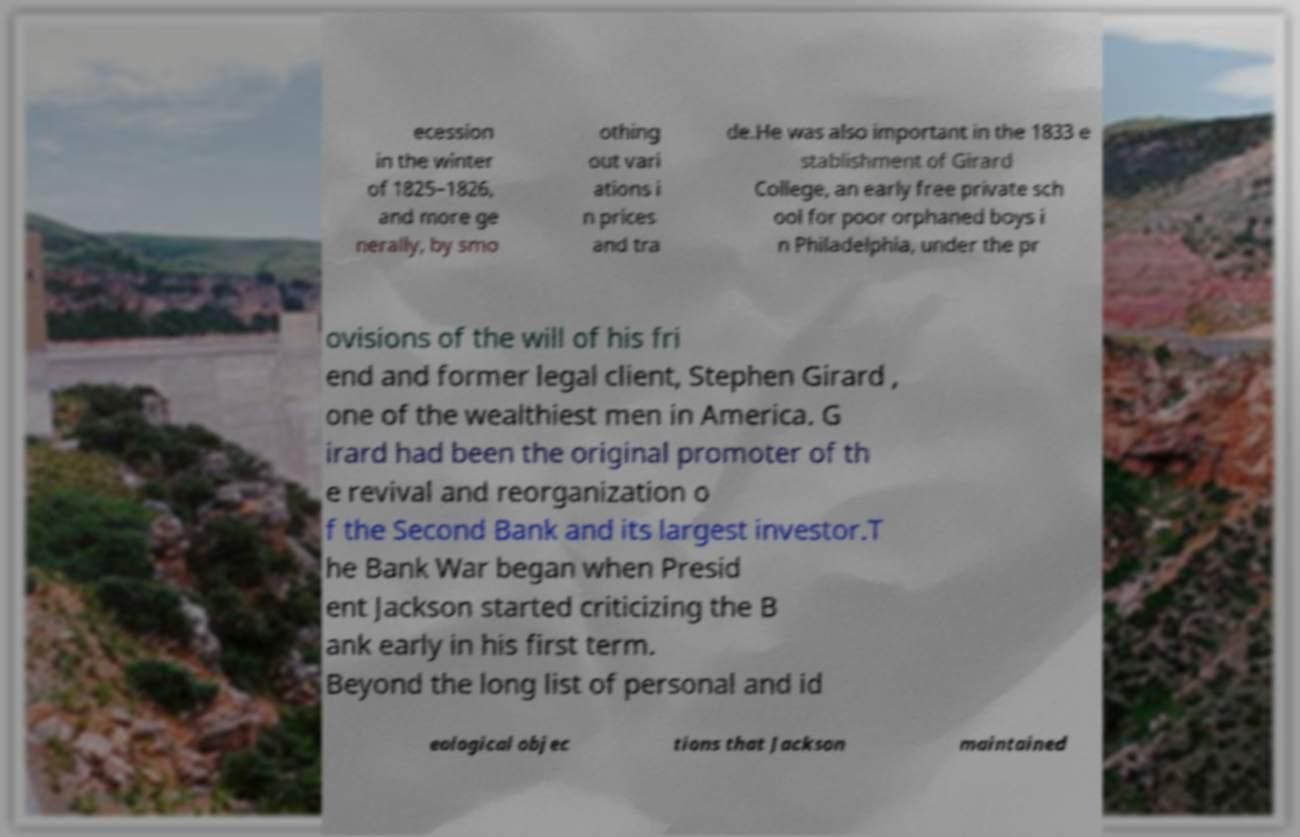Could you extract and type out the text from this image? ecession in the winter of 1825–1826, and more ge nerally, by smo othing out vari ations i n prices and tra de.He was also important in the 1833 e stablishment of Girard College, an early free private sch ool for poor orphaned boys i n Philadelphia, under the pr ovisions of the will of his fri end and former legal client, Stephen Girard , one of the wealthiest men in America. G irard had been the original promoter of th e revival and reorganization o f the Second Bank and its largest investor.T he Bank War began when Presid ent Jackson started criticizing the B ank early in his first term. Beyond the long list of personal and id eological objec tions that Jackson maintained 